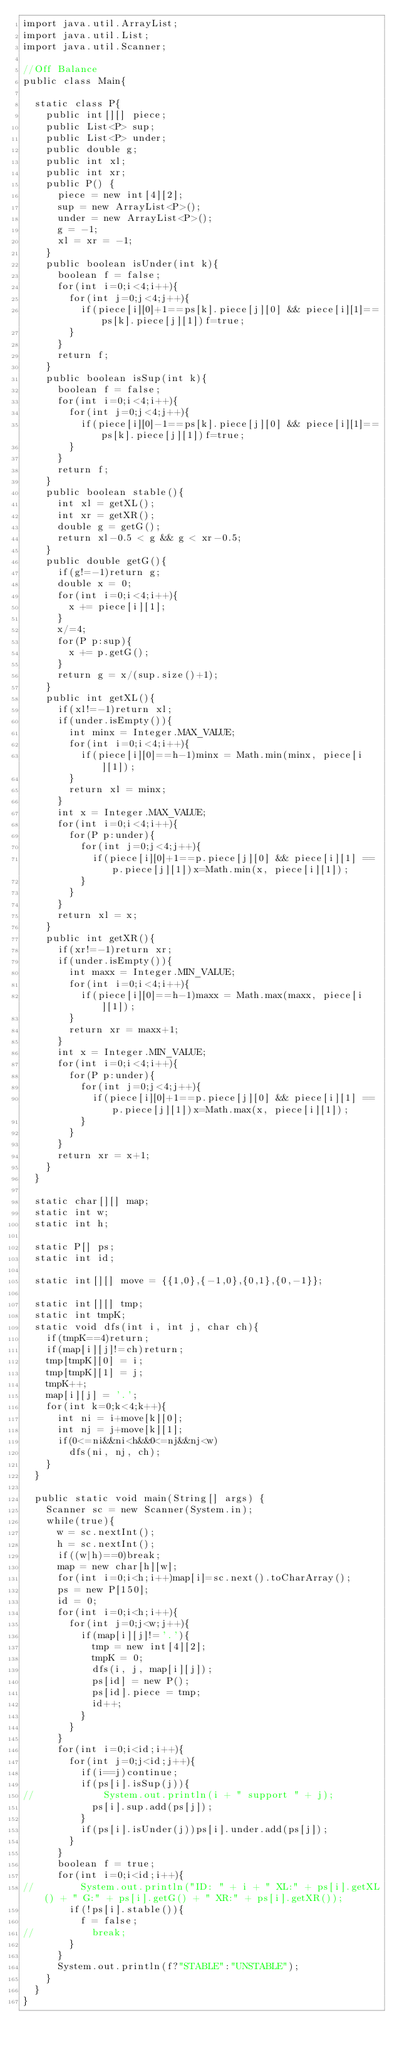Convert code to text. <code><loc_0><loc_0><loc_500><loc_500><_Java_>import java.util.ArrayList;
import java.util.List;
import java.util.Scanner;

//Off Balance
public class Main{

	static class P{
		public int[][] piece;
		public List<P> sup;
		public List<P> under;
		public double g;
		public int xl;
		public int xr;
		public P() {
			piece = new int[4][2];
			sup = new ArrayList<P>();
			under = new ArrayList<P>();
			g = -1;
			xl = xr = -1;
		}
		public boolean isUnder(int k){
			boolean f = false;
			for(int i=0;i<4;i++){
				for(int j=0;j<4;j++){
					if(piece[i][0]+1==ps[k].piece[j][0] && piece[i][1]==ps[k].piece[j][1])f=true;
				}
			}
			return f;
		}
		public boolean isSup(int k){
			boolean f = false;
			for(int i=0;i<4;i++){
				for(int j=0;j<4;j++){
					if(piece[i][0]-1==ps[k].piece[j][0] && piece[i][1]==ps[k].piece[j][1])f=true;
				}
			}
			return f;
		}
		public boolean stable(){
			int xl = getXL();
			int xr = getXR();
			double g = getG();
			return xl-0.5 < g && g < xr-0.5;
		}
		public double getG(){
			if(g!=-1)return g;
			double x = 0;
			for(int i=0;i<4;i++){
				x += piece[i][1];
			}
			x/=4;
			for(P p:sup){
				x += p.getG();
			}
			return g = x/(sup.size()+1);
		}
		public int getXL(){
			if(xl!=-1)return xl;
			if(under.isEmpty()){
				int minx = Integer.MAX_VALUE;
				for(int i=0;i<4;i++){
					if(piece[i][0]==h-1)minx = Math.min(minx, piece[i][1]);
				}
				return xl = minx;
			}
			int x = Integer.MAX_VALUE;
			for(int i=0;i<4;i++){
				for(P p:under){
					for(int j=0;j<4;j++){
						if(piece[i][0]+1==p.piece[j][0] && piece[i][1] == p.piece[j][1])x=Math.min(x, piece[i][1]);
					}
				}
			}
			return xl = x;
		}
		public int getXR(){
			if(xr!=-1)return xr;
			if(under.isEmpty()){
				int maxx = Integer.MIN_VALUE;
				for(int i=0;i<4;i++){
					if(piece[i][0]==h-1)maxx = Math.max(maxx, piece[i][1]);
				}
				return xr = maxx+1;
			}
			int x = Integer.MIN_VALUE;
			for(int i=0;i<4;i++){
				for(P p:under){
					for(int j=0;j<4;j++){
						if(piece[i][0]+1==p.piece[j][0] && piece[i][1] == p.piece[j][1])x=Math.max(x, piece[i][1]);
					}
				}
			}
			return xr = x+1;
		}
	}

	static char[][] map;
	static int w;
	static int h;

	static P[] ps;
	static int id;

	static int[][] move = {{1,0},{-1,0},{0,1},{0,-1}};

	static int[][] tmp;
	static int tmpK;
	static void dfs(int i, int j, char ch){
		if(tmpK==4)return;
		if(map[i][j]!=ch)return;
		tmp[tmpK][0] = i;
		tmp[tmpK][1] = j;
		tmpK++;
		map[i][j] = '.';
		for(int k=0;k<4;k++){
			int ni = i+move[k][0];
			int nj = j+move[k][1];
			if(0<=ni&&ni<h&&0<=nj&&nj<w)
				dfs(ni, nj, ch);
		}
	}

	public static void main(String[] args) {
		Scanner sc = new Scanner(System.in);
		while(true){
			w = sc.nextInt();
			h = sc.nextInt();
			if((w|h)==0)break;
			map = new char[h][w];
			for(int i=0;i<h;i++)map[i]=sc.next().toCharArray();
			ps = new P[150];
			id = 0;
			for(int i=0;i<h;i++){
				for(int j=0;j<w;j++){
					if(map[i][j]!='.'){
						tmp = new int[4][2];
						tmpK = 0;
						dfs(i, j, map[i][j]);
						ps[id] = new P();
						ps[id].piece = tmp;
						id++;
					}
				}
			}
			for(int i=0;i<id;i++){
				for(int j=0;j<id;j++){
					if(i==j)continue;
					if(ps[i].isSup(j)){
//						System.out.println(i + " support " + j);
						ps[i].sup.add(ps[j]);
					}
					if(ps[i].isUnder(j))ps[i].under.add(ps[j]);
				}
			}
			boolean f = true;
			for(int i=0;i<id;i++){
//				System.out.println("ID: " + i + " XL:" + ps[i].getXL() + " G:" + ps[i].getG() + " XR:" + ps[i].getXR());
				if(!ps[i].stable()){
					f = false;
//					break;
				}
			}
			System.out.println(f?"STABLE":"UNSTABLE");
		}
	}
}</code> 